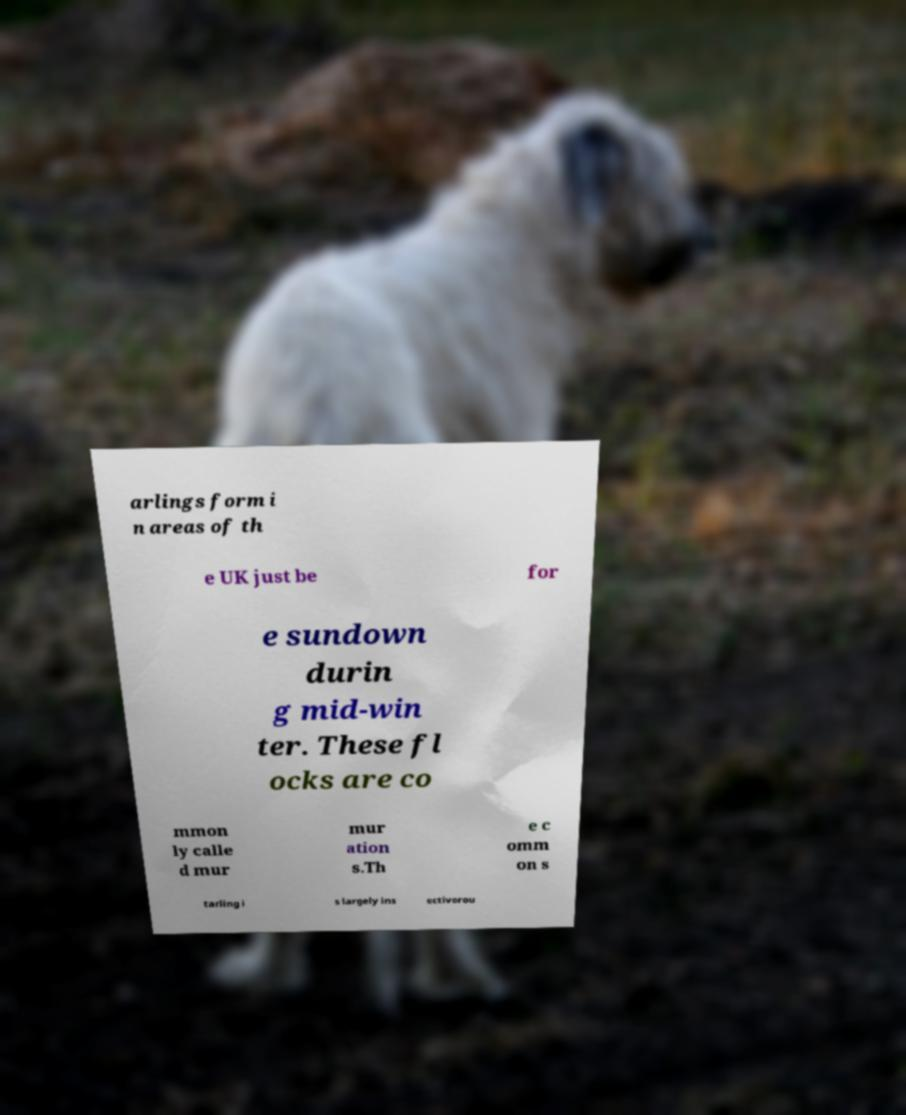I need the written content from this picture converted into text. Can you do that? arlings form i n areas of th e UK just be for e sundown durin g mid-win ter. These fl ocks are co mmon ly calle d mur mur ation s.Th e c omm on s tarling i s largely ins ectivorou 